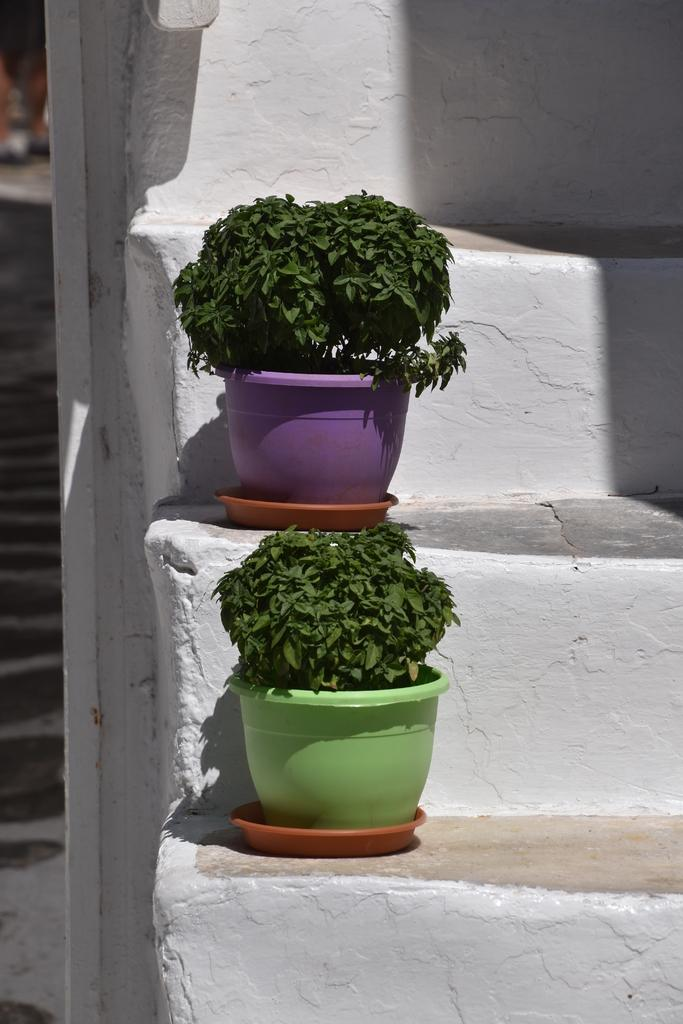What type of living organisms can be seen in the image? Plants can be seen in the image. What color are the plants in the image? The plants are green in color. What are the pots made of, and what colors are they? The pots are made of a material that allows them to hold the plants, and they are in purple and green colors. Where are the pots located in the image? The pots are on stairs in the image. How many cherries can be seen on the plants in the image? There are no cherries present in the image; it features plants in pots on stairs. What type of tool is used to maintain the plants in the image? There is no tool visible in the image that would be used to maintain the plants. 